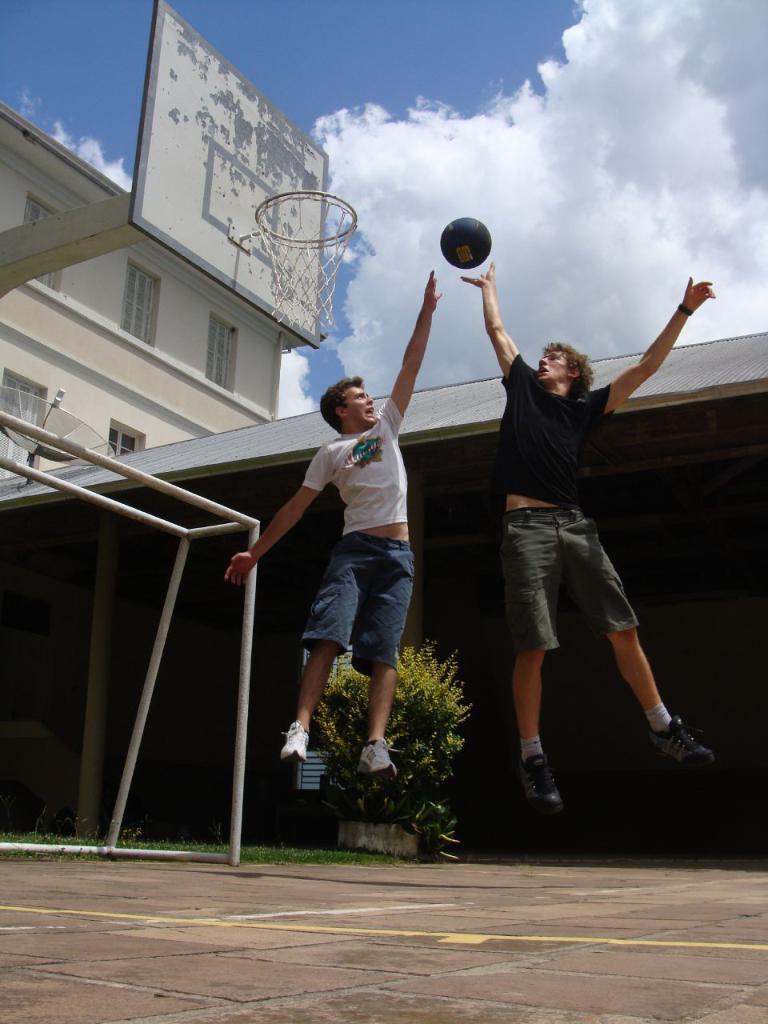How would you summarize this image in a sentence or two? In this image we can see two boys are jumping. One boy is wearing a black T-shirt with shorts and shoes. And the other boy is wearing a white T-shirt, shorts and shoes. At the bottom of the image, we can see the floor. In the background, we can see plant, poles, antenna, basket and buildings. At the top of the image, we can see the sky with some clouds. We can see a ball in the air. 